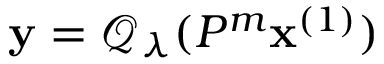Convert formula to latex. <formula><loc_0><loc_0><loc_500><loc_500>y = \mathcal { Q } _ { \lambda } ( P ^ { m } x ^ { ( 1 ) } )</formula> 